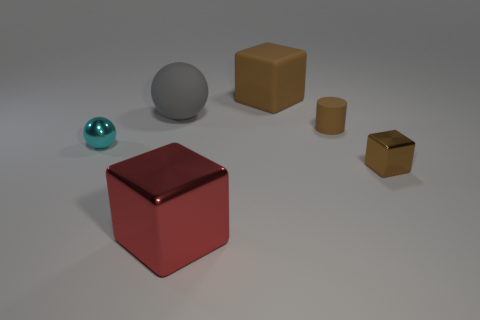How many brown cubes must be subtracted to get 1 brown cubes? 1 Subtract all rubber cubes. How many cubes are left? 2 Subtract all red blocks. How many blocks are left? 2 Subtract all yellow balls. How many brown blocks are left? 2 Subtract all cylinders. How many objects are left? 5 Add 4 blue metal cylinders. How many objects exist? 10 Subtract 2 blocks. How many blocks are left? 1 Add 2 big things. How many big things exist? 5 Subtract 0 purple cylinders. How many objects are left? 6 Subtract all blue blocks. Subtract all gray cylinders. How many blocks are left? 3 